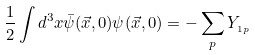<formula> <loc_0><loc_0><loc_500><loc_500>\frac { 1 } { 2 } \int d ^ { 3 } x \bar { \psi } ( \vec { x } , 0 ) \psi ( \vec { x } , 0 ) = - \sum _ { p } Y _ { _ { 1 p } }</formula> 